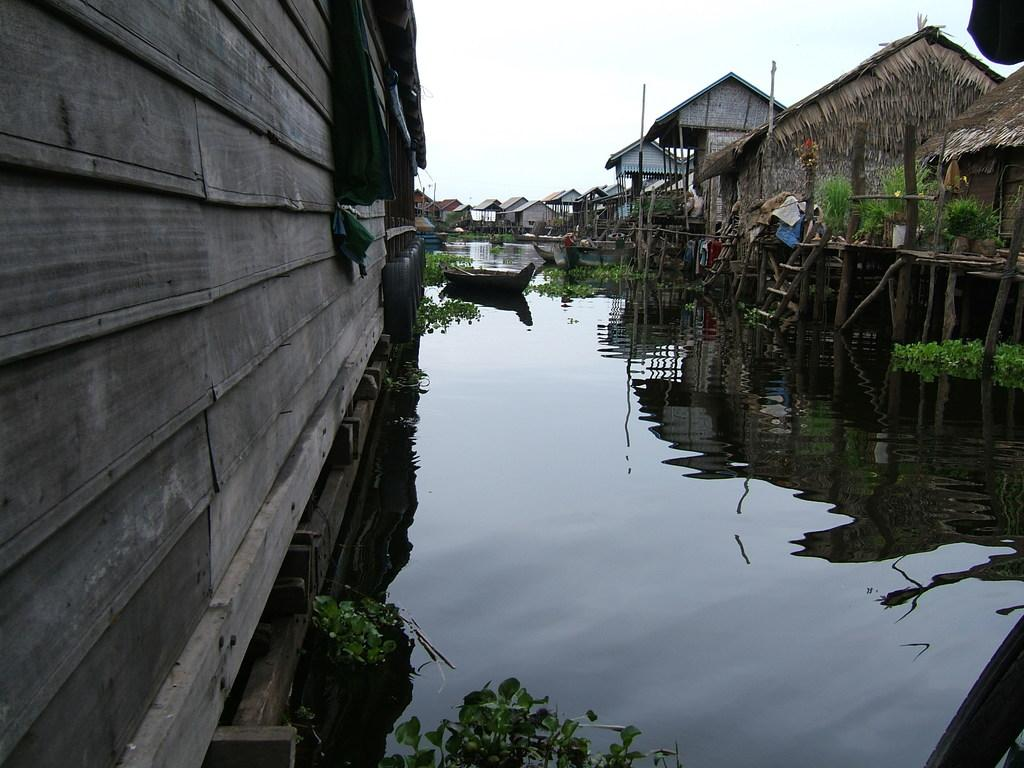What type of structures can be seen in the image? There are sheds and huts in the image. What is located on the water in the image? There is a boat on the water in the image. What type of vegetation is visible in the image? There are plants visible in the image. What type of chess piece is located on the boat in the image? There is no chess piece present on the boat in the image. How many baseball bats can be seen in the image? There are no baseball bats visible in the image. 